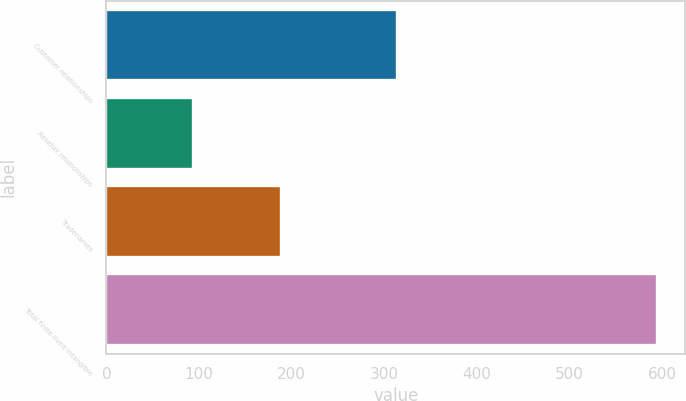<chart> <loc_0><loc_0><loc_500><loc_500><bar_chart><fcel>Customer relationships<fcel>Reseller relationships<fcel>Tradenames<fcel>Total finite-lived intangible<nl><fcel>314<fcel>93<fcel>188<fcel>595<nl></chart> 